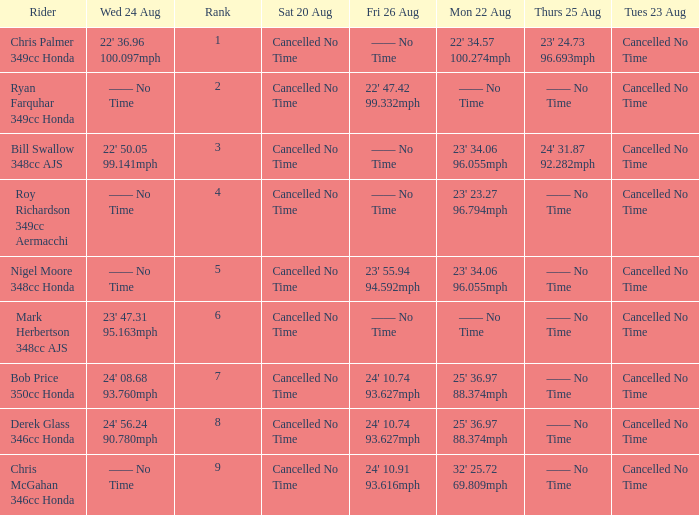What is every entry for Tuesday August 23 when Thursday August 25 is 24' 31.87 92.282mph? Cancelled No Time. 